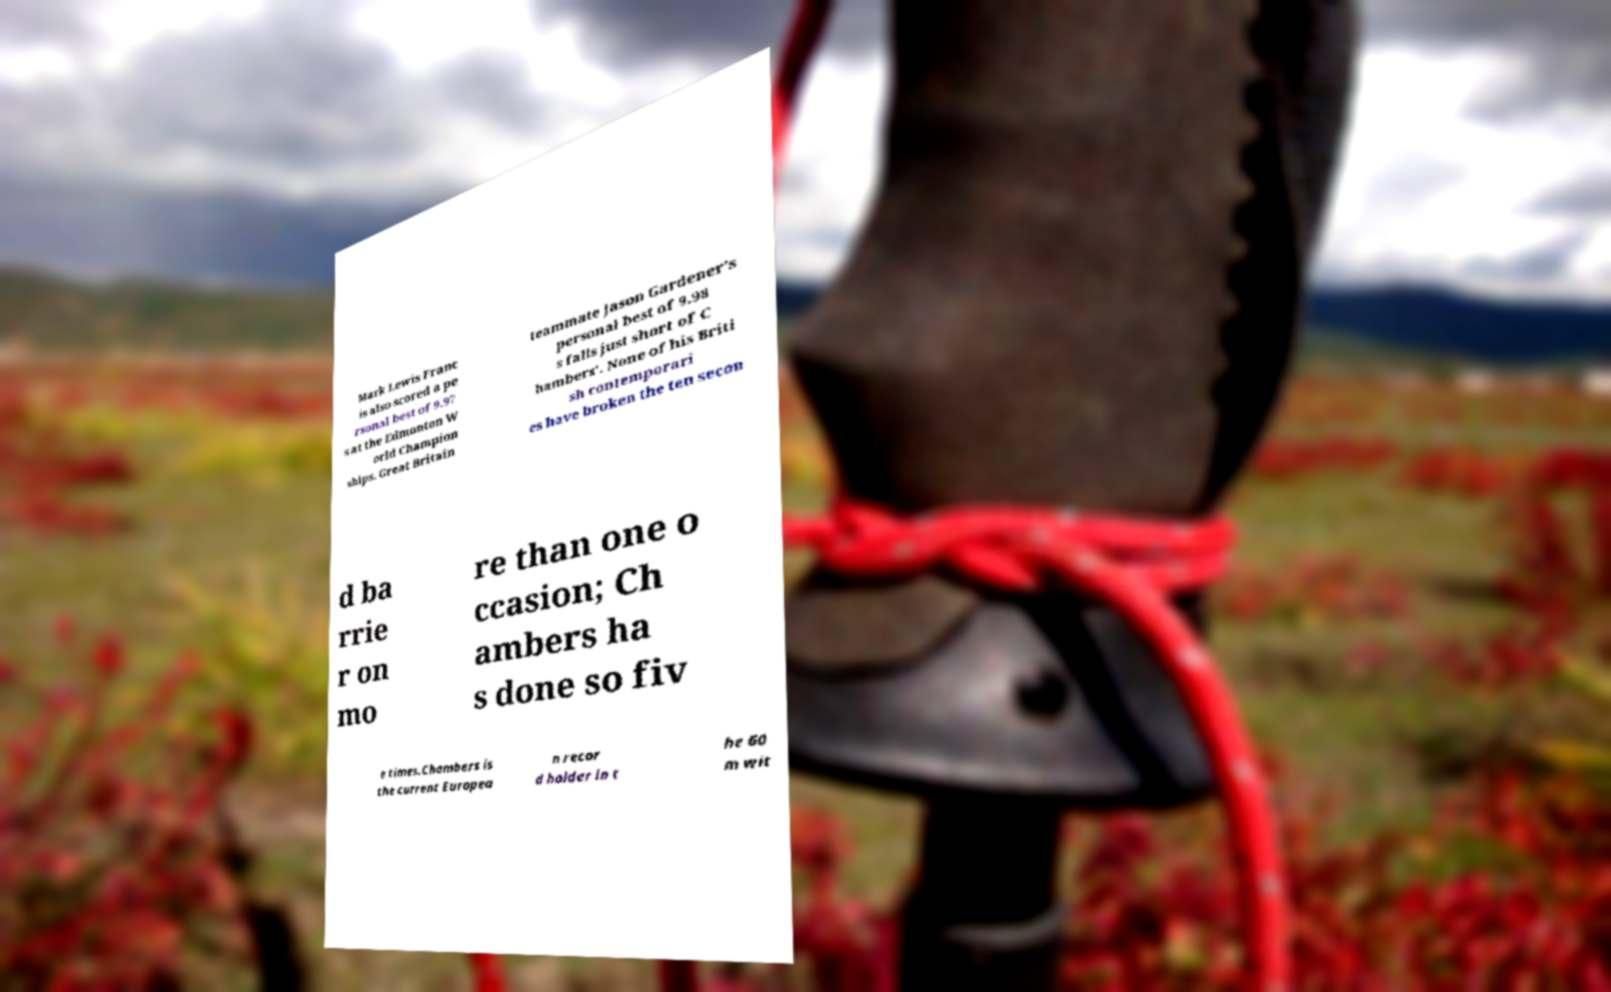For documentation purposes, I need the text within this image transcribed. Could you provide that? Mark Lewis Franc is also scored a pe rsonal best of 9.97 s at the Edmonton W orld Champion ships. Great Britain teammate Jason Gardener's personal best of 9.98 s falls just short of C hambers'. None of his Briti sh contemporari es have broken the ten secon d ba rrie r on mo re than one o ccasion; Ch ambers ha s done so fiv e times.Chambers is the current Europea n recor d holder in t he 60 m wit 